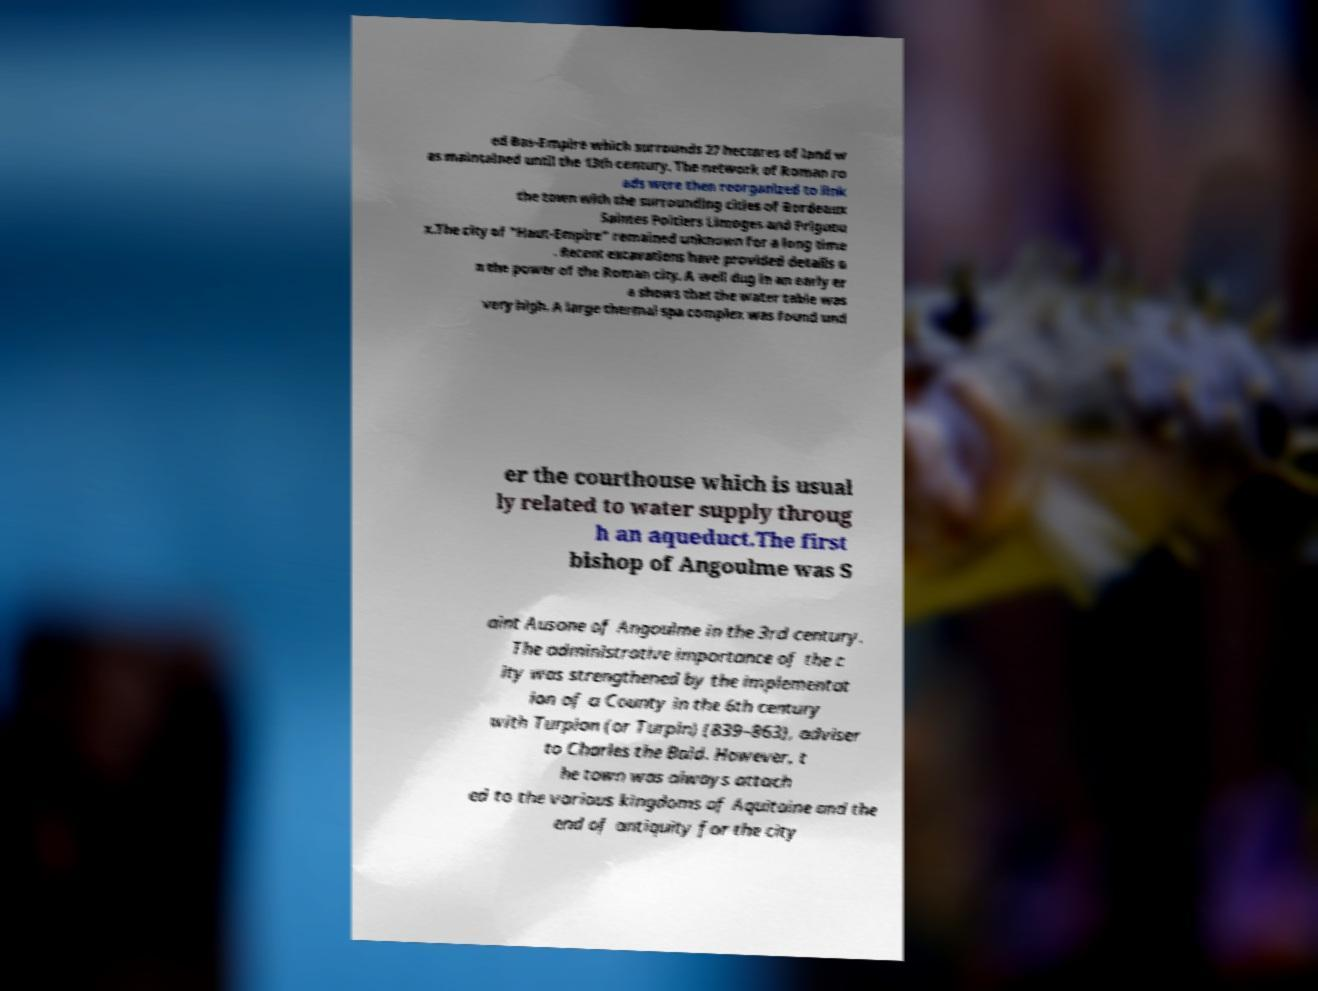There's text embedded in this image that I need extracted. Can you transcribe it verbatim? ed Bas-Empire which surrounds 27 hectares of land w as maintained until the 13th century. The network of Roman ro ads were then reorganized to link the town with the surrounding cities of Bordeaux Saintes Poitiers Limoges and Prigueu x.The city of "Haut-Empire" remained unknown for a long time . Recent excavations have provided details o n the power of the Roman city. A well dug in an early er a shows that the water table was very high. A large thermal spa complex was found und er the courthouse which is usual ly related to water supply throug h an aqueduct.The first bishop of Angoulme was S aint Ausone of Angoulme in the 3rd century. The administrative importance of the c ity was strengthened by the implementat ion of a County in the 6th century with Turpion (or Turpin) (839–863), adviser to Charles the Bald. However, t he town was always attach ed to the various kingdoms of Aquitaine and the end of antiquity for the city 